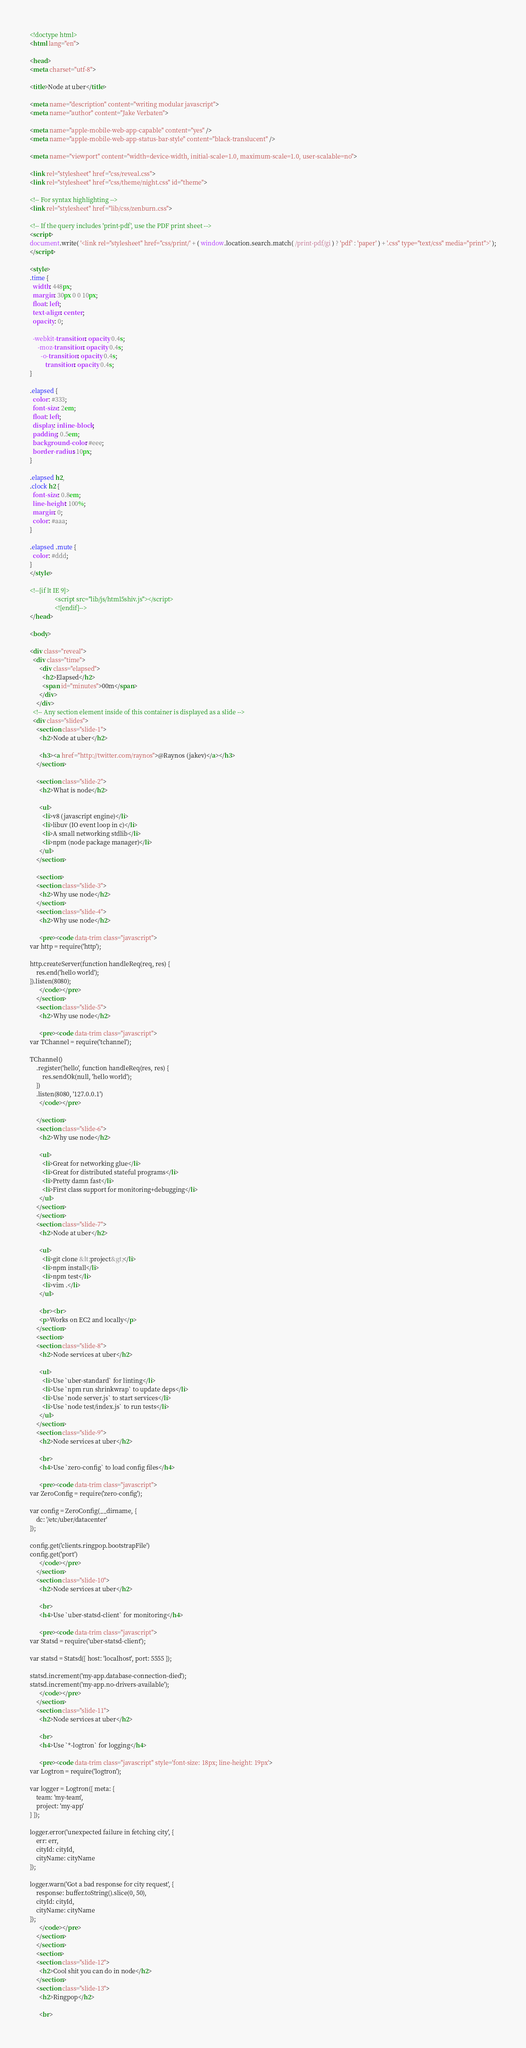<code> <loc_0><loc_0><loc_500><loc_500><_HTML_><!doctype html>
<html lang="en">

<head>
<meta charset="utf-8">

<title>Node at uber</title>

<meta name="description" content="writing modular javascript">
<meta name="author" content="Jake Verbaten">

<meta name="apple-mobile-web-app-capable" content="yes" />
<meta name="apple-mobile-web-app-status-bar-style" content="black-translucent" />

<meta name="viewport" content="width=device-width, initial-scale=1.0, maximum-scale=1.0, user-scalable=no">

<link rel="stylesheet" href="css/reveal.css">
<link rel="stylesheet" href="css/theme/night.css" id="theme">

<!-- For syntax highlighting -->
<link rel="stylesheet" href="lib/css/zenburn.css">

<!-- If the query includes 'print-pdf', use the PDF print sheet -->
<script>
document.write( '<link rel="stylesheet" href="css/print/' + ( window.location.search.match( /print-pdf/gi ) ? 'pdf' : 'paper' ) + '.css" type="text/css" media="print">' );
</script>

<style>
.time {
  width: 448px;
  margin: 30px 0 0 10px;
  float: left;
  text-align: center;
  opacity: 0;

  -webkit-transition: opacity 0.4s;
     -moz-transition: opacity 0.4s;
       -o-transition: opacity 0.4s;
          transition: opacity 0.4s;
}

.elapsed {
  color: #333;
  font-size: 2em;
  float: left;
  display: inline-block;
  padding: 0.5em;
  background-color: #eee;
  border-radius: 10px;
}

.elapsed h2,
.clock h2 {
  font-size: 0.8em;
  line-height: 100%;
  margin: 0;
  color: #aaa;
}

.elapsed .mute {
  color: #ddd;
}
</style>

<!--[if lt IE 9]>
                <script src="lib/js/html5shiv.js"></script>
                <![endif]-->
</head>

<body>

<div class="reveal">
  <div class="time">
      <div class="elapsed">
        <h2>Elapsed</h2>
        <span id="minutes">00m</span>
      </div>
    </div>
  <!-- Any section element inside of this container is displayed as a slide -->
  <div class="slides">
    <section class="slide-1">
      <h2>Node at uber</h2>

      <h3><a href="http://twitter.com/raynos">@Raynos (jakev)</a></h3>
    </section>

    <section class="slide-2">
      <h2>What is node</h2>

      <ul>
        <li>v8 (javascript engine)</li>
        <li>libuv (IO event loop in c)</li>
        <li>A small networking stdlib</li>
        <li>npm (node package manager)</li>
      </ul>
    </section>

    <section>
    <section class="slide-3">
      <h2>Why use node</h2>
    </section>
    <section class="slide-4">
      <h2>Why use node</h2>

      <pre><code data-trim class="javascript">
var http = require('http');

http.createServer(function handleReq(req, res) {
    res.end('hello world');
}).listen(8080);
      </code></pre>
    </section>
    <section class="slide-5">
      <h2>Why use node</h2>

      <pre><code data-trim class="javascript">
var TChannel = require('tchannel');

TChannel()
    .register('hello', function handleReq(res, res) {
        res.sendOk(null, 'hello world');
    })
    .listen(8080, '127.0.0.1')
      </code></pre>

    </section>
    <section class="slide-6">
      <h2>Why use node</h2>

      <ul>
        <li>Great for networking glue</li>
        <li>Great for distributed stateful programs</li>
        <li>Pretty damn fast</li>
        <li>First class support for monitoring+debugging</li>
      </ul>
    </section>
    </section>
    <section class="slide-7">
      <h2>Node at uber</h2>

      <ul>
        <li>git clone &lt;project&gt;</li>
        <li>npm install</li>
        <li>npm test</li>
        <li>vim .</li>
      </ul>

      <br><br>
      <p>Works on EC2 and locally</p>
    </section>
    <section>
    <section class="slide-8">
      <h2>Node services at uber</h2>

      <ul>
        <li>Use `uber-standard` for linting</li>
        <li>Use `npm run shrinkwrap` to update deps</li>
        <li>Use `node server.js` to start services</li>
        <li>Use `node test/index.js` to run tests</li>
      </ul>
    </section>
    <section class="slide-9">
      <h2>Node services at uber</h2>

      <br>
      <h4>Use `zero-config` to load config files</h4>

      <pre><code data-trim class="javascript">
var ZeroConfig = require('zero-config');

var config = ZeroConfig(__dirname, {
    dc: '/etc/uber/datacenter'
});

config.get('clients.ringpop.bootstrapFile')
config.get('port')
      </code></pre>
    </section>
    <section class="slide-10">
      <h2>Node services at uber</h2>

      <br>
      <h4>Use `uber-statsd-client` for monitoring</h4>

      <pre><code data-trim class="javascript">
var Statsd = require('uber-statsd-client');

var statsd = Statsd({ host: 'localhost', port: 5555 });

statsd.increment('my-app.database-connection-died');
statsd.increment('my-app.no-drivers-available');
      </code></pre>
    </section>
    <section class="slide-11">
      <h2>Node services at uber</h2>

      <br>
      <h4>Use `*-logtron` for logging</h4>

      <pre><code data-trim class="javascript" style='font-size: 18px; line-height: 19px'>
var Logtron = require('logtron');

var logger = Logtron({ meta: {
    team: 'my-team',
    project: 'my-app'
} });

logger.error('unexpected failure in fetching city', {
    err: err,
    cityId: cityId,
    cityName: cityName
});

logger.warn('Got a bad response for city request', {
    response: buffer.toString().slice(0, 50),
    cityId: cityId,
    cityName: cityName
});
      </code></pre>
    </section>
    </section>
    <section>
    <section class="slide-12">
      <h2>Cool shit you can do in node</h2>
    </section>
    <section class="slide-13">
      <h2>Ringpop</h2>

      <br></code> 